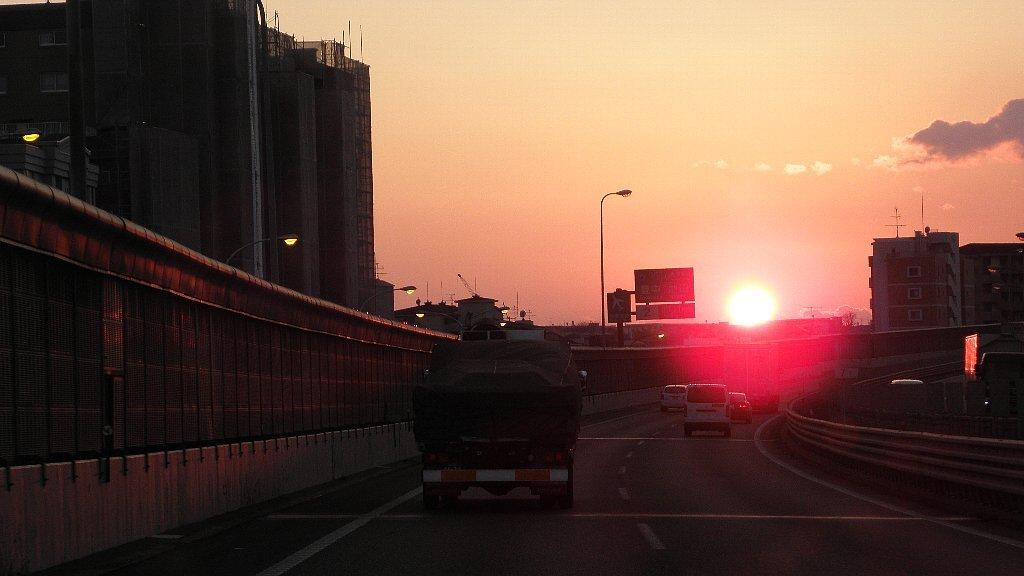What is happening on the road in the image? There are vehicles moving on the road in the image. What can be seen along the road in the image? There is a wall visible in the image, as well as light poles. What else can be seen in the image besides the road and vehicles? Boards are visible in the image. What is visible in the background of the image? There are buildings in the background of the image, and the sky with clouds is visible. Can the sun be seen in the image? Yes, the sun is observable in the sky. What type of ball is being used in the apparatus in the image? There is no ball or apparatus present in the image. What time is displayed on the clock in the image? There is no clock present in the image. 